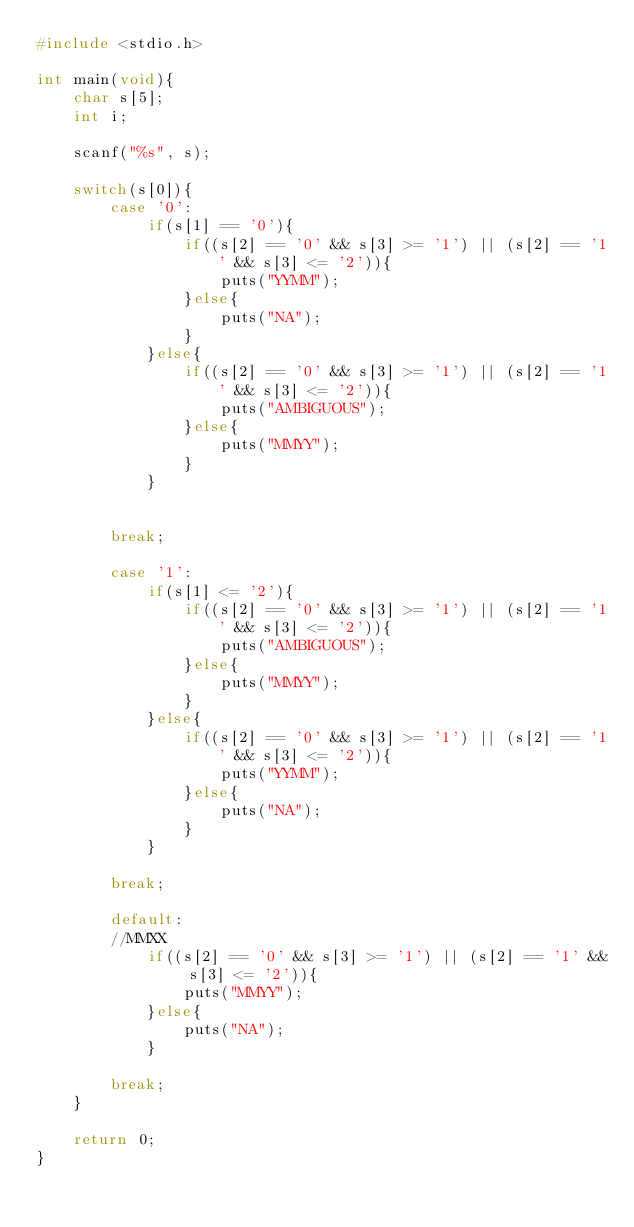Convert code to text. <code><loc_0><loc_0><loc_500><loc_500><_C_>#include <stdio.h>

int main(void){
    char s[5];
    int i;
    
    scanf("%s", s);
    
    switch(s[0]){
        case '0':
            if(s[1] == '0'){
                if((s[2] == '0' && s[3] >= '1') || (s[2] == '1' && s[3] <= '2')){
                    puts("YYMM");
                }else{
                    puts("NA");
                }
            }else{
                if((s[2] == '0' && s[3] >= '1') || (s[2] == '1' && s[3] <= '2')){
                    puts("AMBIGUOUS");
                }else{
                    puts("MMYY");
                }
            }
            
        
        break;
        
        case '1':
            if(s[1] <= '2'){
                if((s[2] == '0' && s[3] >= '1') || (s[2] == '1' && s[3] <= '2')){
                    puts("AMBIGUOUS");
                }else{
                    puts("MMYY");
                }
            }else{
                if((s[2] == '0' && s[3] >= '1') || (s[2] == '1' && s[3] <= '2')){
                    puts("YYMM");
                }else{
                    puts("NA");
                }
            }
        
        break;
        
        default:
        //MMXX
            if((s[2] == '0' && s[3] >= '1') || (s[2] == '1' && s[3] <= '2')){
                puts("MMYY");
            }else{
                puts("NA");
            }
        
        break;
    }
    
    return 0;
}</code> 